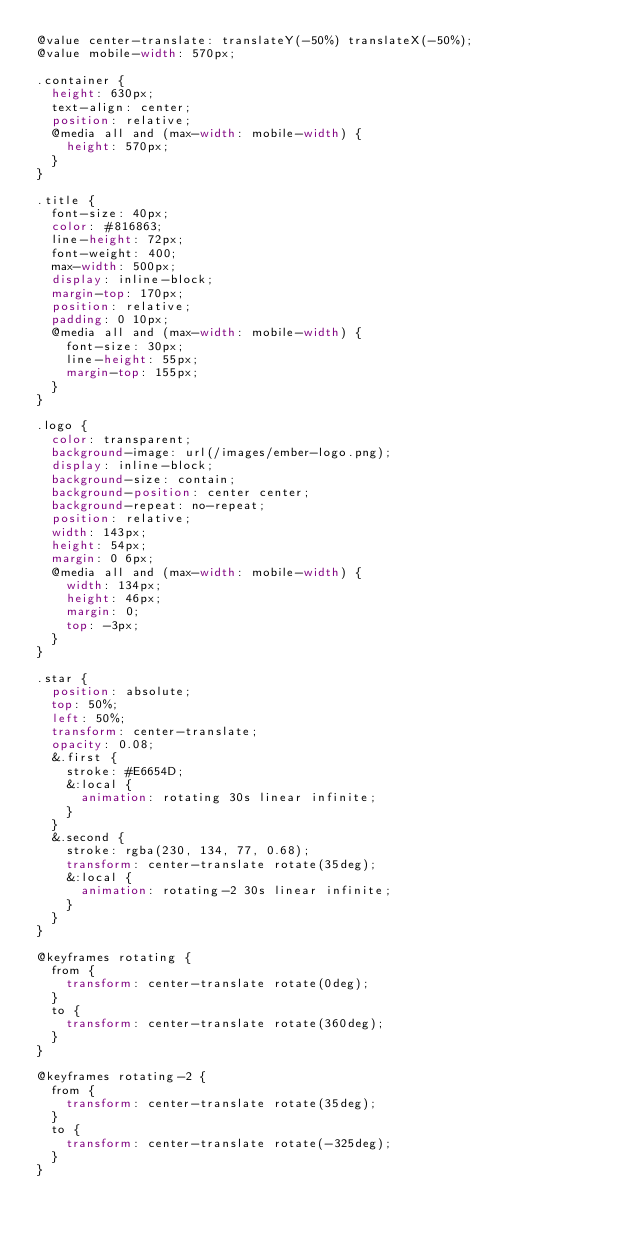Convert code to text. <code><loc_0><loc_0><loc_500><loc_500><_CSS_>@value center-translate: translateY(-50%) translateX(-50%);
@value mobile-width: 570px;

.container {
  height: 630px;  
  text-align: center;
  position: relative;
  @media all and (max-width: mobile-width) {
    height: 570px;
  }
}

.title {
  font-size: 40px;
  color: #816863;
  line-height: 72px;
  font-weight: 400;
  max-width: 500px;
  display: inline-block;
  margin-top: 170px;
  position: relative;
  padding: 0 10px;
  @media all and (max-width: mobile-width) {
    font-size: 30px;
    line-height: 55px;
    margin-top: 155px;
  }
}

.logo {
  color: transparent;
  background-image: url(/images/ember-logo.png);
  display: inline-block;
  background-size: contain;
  background-position: center center;
  background-repeat: no-repeat;
  position: relative;
  width: 143px;
  height: 54px;
  margin: 0 6px;
  @media all and (max-width: mobile-width) {
    width: 134px;
    height: 46px;
    margin: 0;
    top: -3px;
  }
}

.star {
  position: absolute;
  top: 50%;
  left: 50%;
  transform: center-translate;
  opacity: 0.08;
  &.first {
    stroke: #E6654D;
    &:local {
      animation: rotating 30s linear infinite;
    }
  }
  &.second {
    stroke: rgba(230, 134, 77, 0.68);
    transform: center-translate rotate(35deg);
    &:local {
      animation: rotating-2 30s linear infinite;
    }
  }
}

@keyframes rotating {
  from {
    transform: center-translate rotate(0deg);
  }
  to {
    transform: center-translate rotate(360deg);
  }
}

@keyframes rotating-2 {
  from {
    transform: center-translate rotate(35deg);
  }
  to {
    transform: center-translate rotate(-325deg);
  }
}

</code> 